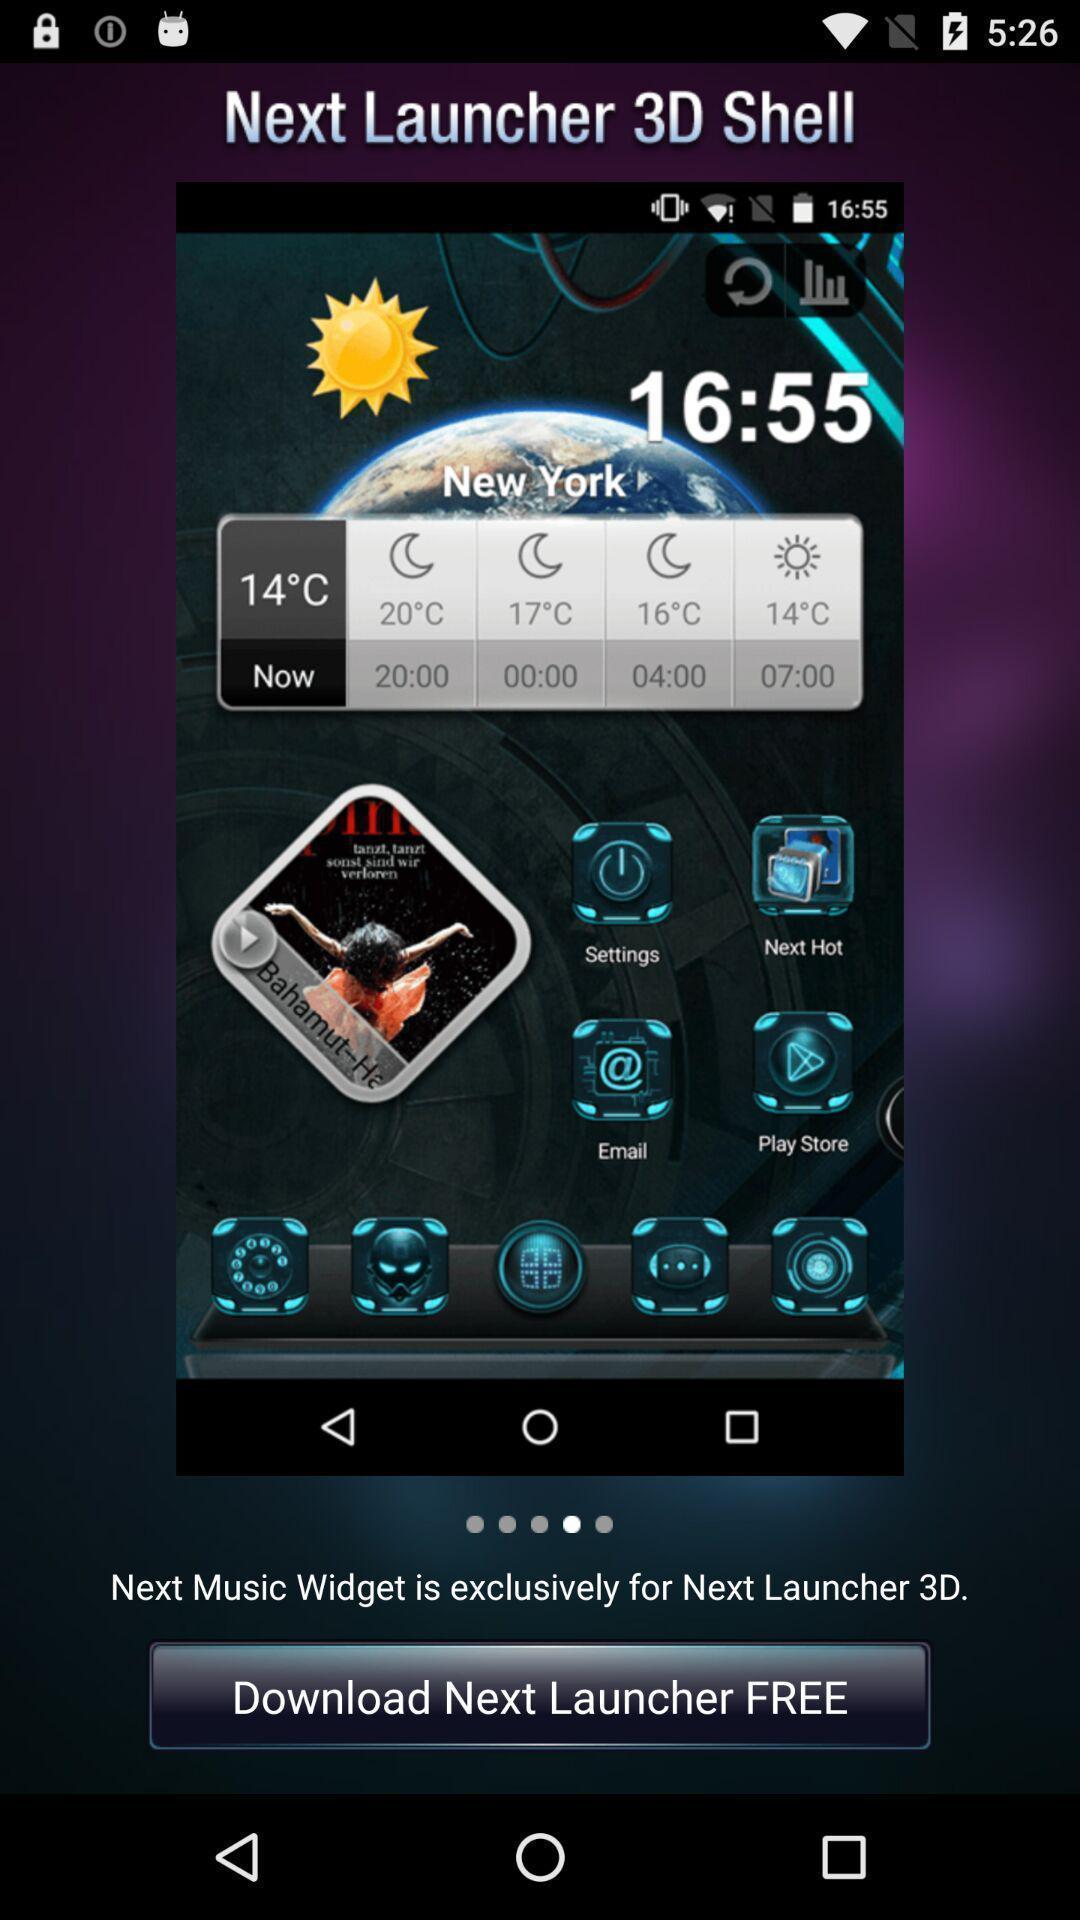What can you discern from this picture? Page showing a suggestion about an app. 